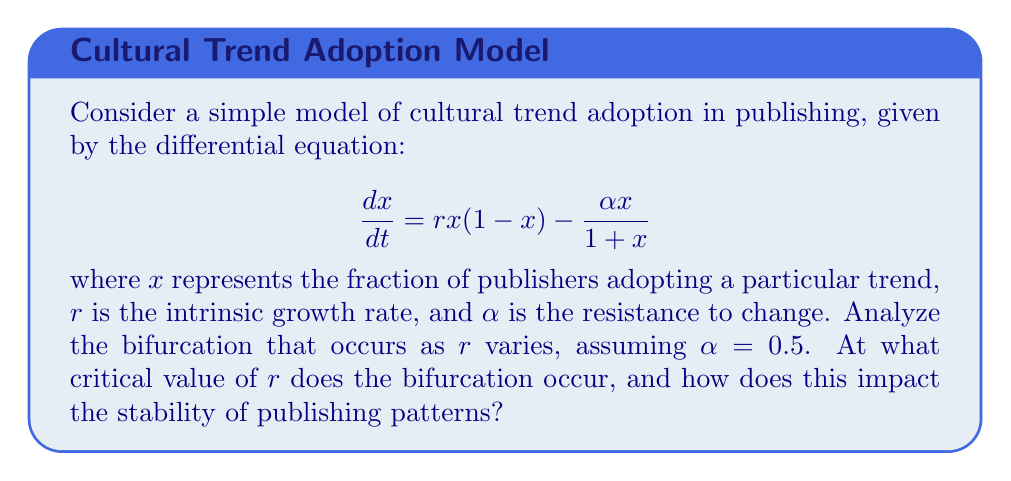Show me your answer to this math problem. To analyze the bifurcation, we need to follow these steps:

1) Find the equilibrium points by setting $\frac{dx}{dt} = 0$:

   $$ rx(1-x) - \frac{\alpha x}{1+x} = 0 $$

2) Factor out $x$:

   $$ x\left(r(1-x) - \frac{\alpha}{1+x}\right) = 0 $$

3) One equilibrium point is $x_1 = 0$. For the other(s), solve:

   $$ r(1-x) - \frac{\alpha}{1+x} = 0 $$

4) Multiply both sides by $(1+x)$:

   $$ r(1-x)(1+x) - \alpha = 0 $$
   $$ r(1-x^2) - \alpha = 0 $$
   $$ r - rx^2 - \alpha = 0 $$
   $$ rx^2 - r + \alpha = 0 $$

5) This is a quadratic equation. For a bifurcation to occur, this equation should have a double root, which happens when its discriminant is zero. The discriminant is:

   $$ b^2 - 4ac = (-r)^2 - 4r\alpha = r^2 - 4r\alpha = 0 $$

6) Solve this equation for $r$:

   $$ r^2 - 4r\alpha = 0 $$
   $$ r(r - 4\alpha) = 0 $$
   $$ r = 0 \text{ or } r = 4\alpha $$

7) Since $r$ represents growth rate, $r = 0$ is not meaningful. Therefore, the critical value is:

   $$ r_c = 4\alpha = 4(0.5) = 2 $$

8) For $r < 2$, the system has one stable equilibrium at $x = 0$. For $r > 2$, $x = 0$ becomes unstable, and a new stable equilibrium appears, representing the adoption of the trend.

This bifurcation represents a transition from a state where new trends fail to gain traction (when $r < 2$) to a state where trends can be sustainably adopted (when $r > 2$), significantly impacting publishing patterns.
Answer: $r_c = 2$ 